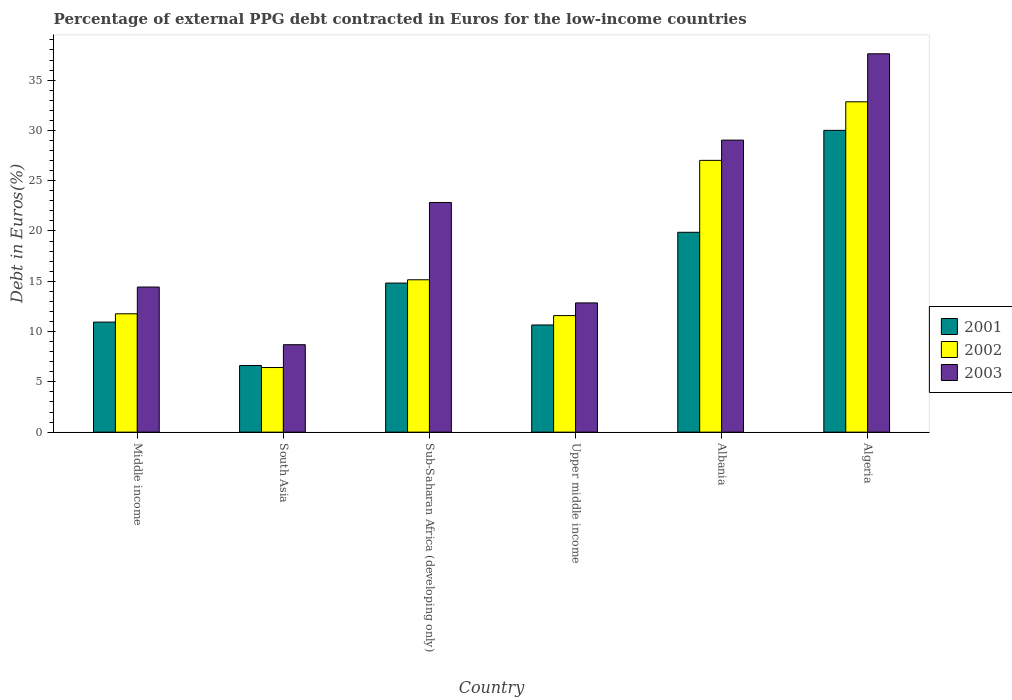How many groups of bars are there?
Offer a terse response. 6. How many bars are there on the 2nd tick from the left?
Offer a very short reply. 3. What is the label of the 6th group of bars from the left?
Your response must be concise. Algeria. In how many cases, is the number of bars for a given country not equal to the number of legend labels?
Keep it short and to the point. 0. What is the percentage of external PPG debt contracted in Euros in 2003 in Albania?
Make the answer very short. 29.04. Across all countries, what is the maximum percentage of external PPG debt contracted in Euros in 2003?
Provide a short and direct response. 37.62. Across all countries, what is the minimum percentage of external PPG debt contracted in Euros in 2001?
Provide a short and direct response. 6.62. In which country was the percentage of external PPG debt contracted in Euros in 2003 maximum?
Provide a succinct answer. Algeria. In which country was the percentage of external PPG debt contracted in Euros in 2001 minimum?
Ensure brevity in your answer.  South Asia. What is the total percentage of external PPG debt contracted in Euros in 2001 in the graph?
Your answer should be compact. 92.92. What is the difference between the percentage of external PPG debt contracted in Euros in 2002 in Algeria and that in Sub-Saharan Africa (developing only)?
Give a very brief answer. 17.7. What is the difference between the percentage of external PPG debt contracted in Euros in 2003 in Middle income and the percentage of external PPG debt contracted in Euros in 2001 in South Asia?
Your answer should be compact. 7.8. What is the average percentage of external PPG debt contracted in Euros in 2002 per country?
Your response must be concise. 17.47. What is the difference between the percentage of external PPG debt contracted in Euros of/in 2001 and percentage of external PPG debt contracted in Euros of/in 2003 in Sub-Saharan Africa (developing only)?
Provide a short and direct response. -8.01. In how many countries, is the percentage of external PPG debt contracted in Euros in 2002 greater than 16 %?
Provide a succinct answer. 2. What is the ratio of the percentage of external PPG debt contracted in Euros in 2002 in Albania to that in Middle income?
Your answer should be very brief. 2.3. Is the percentage of external PPG debt contracted in Euros in 2003 in Algeria less than that in Sub-Saharan Africa (developing only)?
Your answer should be compact. No. What is the difference between the highest and the second highest percentage of external PPG debt contracted in Euros in 2001?
Provide a succinct answer. -10.14. What is the difference between the highest and the lowest percentage of external PPG debt contracted in Euros in 2003?
Your response must be concise. 28.93. Are all the bars in the graph horizontal?
Provide a short and direct response. No. Does the graph contain grids?
Your answer should be very brief. No. Where does the legend appear in the graph?
Ensure brevity in your answer.  Center right. What is the title of the graph?
Your response must be concise. Percentage of external PPG debt contracted in Euros for the low-income countries. Does "1980" appear as one of the legend labels in the graph?
Keep it short and to the point. No. What is the label or title of the Y-axis?
Your response must be concise. Debt in Euros(%). What is the Debt in Euros(%) in 2001 in Middle income?
Give a very brief answer. 10.94. What is the Debt in Euros(%) of 2002 in Middle income?
Ensure brevity in your answer.  11.77. What is the Debt in Euros(%) in 2003 in Middle income?
Provide a succinct answer. 14.43. What is the Debt in Euros(%) in 2001 in South Asia?
Offer a terse response. 6.62. What is the Debt in Euros(%) in 2002 in South Asia?
Ensure brevity in your answer.  6.43. What is the Debt in Euros(%) of 2003 in South Asia?
Offer a very short reply. 8.69. What is the Debt in Euros(%) of 2001 in Sub-Saharan Africa (developing only)?
Make the answer very short. 14.82. What is the Debt in Euros(%) of 2002 in Sub-Saharan Africa (developing only)?
Offer a very short reply. 15.15. What is the Debt in Euros(%) in 2003 in Sub-Saharan Africa (developing only)?
Your answer should be very brief. 22.84. What is the Debt in Euros(%) in 2001 in Upper middle income?
Offer a very short reply. 10.66. What is the Debt in Euros(%) of 2002 in Upper middle income?
Ensure brevity in your answer.  11.59. What is the Debt in Euros(%) in 2003 in Upper middle income?
Provide a short and direct response. 12.85. What is the Debt in Euros(%) of 2001 in Albania?
Your answer should be very brief. 19.87. What is the Debt in Euros(%) in 2002 in Albania?
Provide a short and direct response. 27.02. What is the Debt in Euros(%) of 2003 in Albania?
Provide a succinct answer. 29.04. What is the Debt in Euros(%) in 2001 in Algeria?
Offer a terse response. 30.01. What is the Debt in Euros(%) in 2002 in Algeria?
Your answer should be compact. 32.85. What is the Debt in Euros(%) in 2003 in Algeria?
Make the answer very short. 37.62. Across all countries, what is the maximum Debt in Euros(%) of 2001?
Your answer should be very brief. 30.01. Across all countries, what is the maximum Debt in Euros(%) in 2002?
Offer a very short reply. 32.85. Across all countries, what is the maximum Debt in Euros(%) of 2003?
Offer a very short reply. 37.62. Across all countries, what is the minimum Debt in Euros(%) of 2001?
Your answer should be very brief. 6.62. Across all countries, what is the minimum Debt in Euros(%) in 2002?
Give a very brief answer. 6.43. Across all countries, what is the minimum Debt in Euros(%) of 2003?
Your response must be concise. 8.69. What is the total Debt in Euros(%) of 2001 in the graph?
Ensure brevity in your answer.  92.92. What is the total Debt in Euros(%) in 2002 in the graph?
Give a very brief answer. 104.8. What is the total Debt in Euros(%) of 2003 in the graph?
Your answer should be very brief. 125.46. What is the difference between the Debt in Euros(%) in 2001 in Middle income and that in South Asia?
Your answer should be very brief. 4.32. What is the difference between the Debt in Euros(%) of 2002 in Middle income and that in South Asia?
Make the answer very short. 5.34. What is the difference between the Debt in Euros(%) of 2003 in Middle income and that in South Asia?
Ensure brevity in your answer.  5.73. What is the difference between the Debt in Euros(%) in 2001 in Middle income and that in Sub-Saharan Africa (developing only)?
Provide a short and direct response. -3.88. What is the difference between the Debt in Euros(%) in 2002 in Middle income and that in Sub-Saharan Africa (developing only)?
Your answer should be compact. -3.38. What is the difference between the Debt in Euros(%) of 2003 in Middle income and that in Sub-Saharan Africa (developing only)?
Your answer should be very brief. -8.41. What is the difference between the Debt in Euros(%) of 2001 in Middle income and that in Upper middle income?
Your answer should be very brief. 0.29. What is the difference between the Debt in Euros(%) in 2002 in Middle income and that in Upper middle income?
Give a very brief answer. 0.18. What is the difference between the Debt in Euros(%) in 2003 in Middle income and that in Upper middle income?
Your answer should be compact. 1.58. What is the difference between the Debt in Euros(%) in 2001 in Middle income and that in Albania?
Your answer should be very brief. -8.93. What is the difference between the Debt in Euros(%) in 2002 in Middle income and that in Albania?
Ensure brevity in your answer.  -15.25. What is the difference between the Debt in Euros(%) of 2003 in Middle income and that in Albania?
Provide a succinct answer. -14.61. What is the difference between the Debt in Euros(%) of 2001 in Middle income and that in Algeria?
Give a very brief answer. -19.06. What is the difference between the Debt in Euros(%) in 2002 in Middle income and that in Algeria?
Provide a short and direct response. -21.08. What is the difference between the Debt in Euros(%) of 2003 in Middle income and that in Algeria?
Give a very brief answer. -23.19. What is the difference between the Debt in Euros(%) in 2001 in South Asia and that in Sub-Saharan Africa (developing only)?
Ensure brevity in your answer.  -8.2. What is the difference between the Debt in Euros(%) in 2002 in South Asia and that in Sub-Saharan Africa (developing only)?
Provide a short and direct response. -8.72. What is the difference between the Debt in Euros(%) in 2003 in South Asia and that in Sub-Saharan Africa (developing only)?
Offer a terse response. -14.14. What is the difference between the Debt in Euros(%) in 2001 in South Asia and that in Upper middle income?
Offer a very short reply. -4.03. What is the difference between the Debt in Euros(%) in 2002 in South Asia and that in Upper middle income?
Your answer should be very brief. -5.16. What is the difference between the Debt in Euros(%) of 2003 in South Asia and that in Upper middle income?
Your answer should be very brief. -4.16. What is the difference between the Debt in Euros(%) in 2001 in South Asia and that in Albania?
Give a very brief answer. -13.25. What is the difference between the Debt in Euros(%) in 2002 in South Asia and that in Albania?
Offer a terse response. -20.6. What is the difference between the Debt in Euros(%) in 2003 in South Asia and that in Albania?
Offer a terse response. -20.34. What is the difference between the Debt in Euros(%) of 2001 in South Asia and that in Algeria?
Provide a short and direct response. -23.38. What is the difference between the Debt in Euros(%) of 2002 in South Asia and that in Algeria?
Make the answer very short. -26.42. What is the difference between the Debt in Euros(%) of 2003 in South Asia and that in Algeria?
Provide a succinct answer. -28.93. What is the difference between the Debt in Euros(%) in 2001 in Sub-Saharan Africa (developing only) and that in Upper middle income?
Offer a very short reply. 4.17. What is the difference between the Debt in Euros(%) of 2002 in Sub-Saharan Africa (developing only) and that in Upper middle income?
Provide a short and direct response. 3.56. What is the difference between the Debt in Euros(%) in 2003 in Sub-Saharan Africa (developing only) and that in Upper middle income?
Your response must be concise. 9.99. What is the difference between the Debt in Euros(%) in 2001 in Sub-Saharan Africa (developing only) and that in Albania?
Your answer should be very brief. -5.05. What is the difference between the Debt in Euros(%) in 2002 in Sub-Saharan Africa (developing only) and that in Albania?
Your response must be concise. -11.87. What is the difference between the Debt in Euros(%) in 2003 in Sub-Saharan Africa (developing only) and that in Albania?
Your response must be concise. -6.2. What is the difference between the Debt in Euros(%) of 2001 in Sub-Saharan Africa (developing only) and that in Algeria?
Offer a very short reply. -15.18. What is the difference between the Debt in Euros(%) of 2002 in Sub-Saharan Africa (developing only) and that in Algeria?
Your answer should be compact. -17.7. What is the difference between the Debt in Euros(%) of 2003 in Sub-Saharan Africa (developing only) and that in Algeria?
Offer a very short reply. -14.78. What is the difference between the Debt in Euros(%) in 2001 in Upper middle income and that in Albania?
Give a very brief answer. -9.22. What is the difference between the Debt in Euros(%) of 2002 in Upper middle income and that in Albania?
Your answer should be very brief. -15.43. What is the difference between the Debt in Euros(%) in 2003 in Upper middle income and that in Albania?
Make the answer very short. -16.19. What is the difference between the Debt in Euros(%) in 2001 in Upper middle income and that in Algeria?
Provide a succinct answer. -19.35. What is the difference between the Debt in Euros(%) in 2002 in Upper middle income and that in Algeria?
Your answer should be very brief. -21.26. What is the difference between the Debt in Euros(%) of 2003 in Upper middle income and that in Algeria?
Your response must be concise. -24.77. What is the difference between the Debt in Euros(%) of 2001 in Albania and that in Algeria?
Your response must be concise. -10.14. What is the difference between the Debt in Euros(%) of 2002 in Albania and that in Algeria?
Ensure brevity in your answer.  -5.82. What is the difference between the Debt in Euros(%) in 2003 in Albania and that in Algeria?
Your response must be concise. -8.58. What is the difference between the Debt in Euros(%) in 2001 in Middle income and the Debt in Euros(%) in 2002 in South Asia?
Offer a terse response. 4.52. What is the difference between the Debt in Euros(%) of 2001 in Middle income and the Debt in Euros(%) of 2003 in South Asia?
Provide a succinct answer. 2.25. What is the difference between the Debt in Euros(%) in 2002 in Middle income and the Debt in Euros(%) in 2003 in South Asia?
Your answer should be compact. 3.07. What is the difference between the Debt in Euros(%) of 2001 in Middle income and the Debt in Euros(%) of 2002 in Sub-Saharan Africa (developing only)?
Provide a short and direct response. -4.21. What is the difference between the Debt in Euros(%) of 2001 in Middle income and the Debt in Euros(%) of 2003 in Sub-Saharan Africa (developing only)?
Your answer should be compact. -11.89. What is the difference between the Debt in Euros(%) of 2002 in Middle income and the Debt in Euros(%) of 2003 in Sub-Saharan Africa (developing only)?
Provide a short and direct response. -11.07. What is the difference between the Debt in Euros(%) in 2001 in Middle income and the Debt in Euros(%) in 2002 in Upper middle income?
Your answer should be very brief. -0.64. What is the difference between the Debt in Euros(%) in 2001 in Middle income and the Debt in Euros(%) in 2003 in Upper middle income?
Keep it short and to the point. -1.91. What is the difference between the Debt in Euros(%) of 2002 in Middle income and the Debt in Euros(%) of 2003 in Upper middle income?
Your response must be concise. -1.08. What is the difference between the Debt in Euros(%) of 2001 in Middle income and the Debt in Euros(%) of 2002 in Albania?
Offer a very short reply. -16.08. What is the difference between the Debt in Euros(%) in 2001 in Middle income and the Debt in Euros(%) in 2003 in Albania?
Provide a short and direct response. -18.09. What is the difference between the Debt in Euros(%) in 2002 in Middle income and the Debt in Euros(%) in 2003 in Albania?
Provide a succinct answer. -17.27. What is the difference between the Debt in Euros(%) in 2001 in Middle income and the Debt in Euros(%) in 2002 in Algeria?
Offer a terse response. -21.9. What is the difference between the Debt in Euros(%) of 2001 in Middle income and the Debt in Euros(%) of 2003 in Algeria?
Offer a very short reply. -26.68. What is the difference between the Debt in Euros(%) in 2002 in Middle income and the Debt in Euros(%) in 2003 in Algeria?
Your response must be concise. -25.85. What is the difference between the Debt in Euros(%) in 2001 in South Asia and the Debt in Euros(%) in 2002 in Sub-Saharan Africa (developing only)?
Provide a succinct answer. -8.53. What is the difference between the Debt in Euros(%) in 2001 in South Asia and the Debt in Euros(%) in 2003 in Sub-Saharan Africa (developing only)?
Offer a terse response. -16.21. What is the difference between the Debt in Euros(%) in 2002 in South Asia and the Debt in Euros(%) in 2003 in Sub-Saharan Africa (developing only)?
Offer a terse response. -16.41. What is the difference between the Debt in Euros(%) in 2001 in South Asia and the Debt in Euros(%) in 2002 in Upper middle income?
Your answer should be compact. -4.96. What is the difference between the Debt in Euros(%) of 2001 in South Asia and the Debt in Euros(%) of 2003 in Upper middle income?
Provide a succinct answer. -6.23. What is the difference between the Debt in Euros(%) of 2002 in South Asia and the Debt in Euros(%) of 2003 in Upper middle income?
Offer a very short reply. -6.42. What is the difference between the Debt in Euros(%) in 2001 in South Asia and the Debt in Euros(%) in 2002 in Albania?
Keep it short and to the point. -20.4. What is the difference between the Debt in Euros(%) in 2001 in South Asia and the Debt in Euros(%) in 2003 in Albania?
Ensure brevity in your answer.  -22.41. What is the difference between the Debt in Euros(%) of 2002 in South Asia and the Debt in Euros(%) of 2003 in Albania?
Offer a very short reply. -22.61. What is the difference between the Debt in Euros(%) in 2001 in South Asia and the Debt in Euros(%) in 2002 in Algeria?
Ensure brevity in your answer.  -26.22. What is the difference between the Debt in Euros(%) in 2001 in South Asia and the Debt in Euros(%) in 2003 in Algeria?
Offer a terse response. -31. What is the difference between the Debt in Euros(%) of 2002 in South Asia and the Debt in Euros(%) of 2003 in Algeria?
Ensure brevity in your answer.  -31.19. What is the difference between the Debt in Euros(%) of 2001 in Sub-Saharan Africa (developing only) and the Debt in Euros(%) of 2002 in Upper middle income?
Your answer should be compact. 3.23. What is the difference between the Debt in Euros(%) in 2001 in Sub-Saharan Africa (developing only) and the Debt in Euros(%) in 2003 in Upper middle income?
Offer a terse response. 1.97. What is the difference between the Debt in Euros(%) in 2002 in Sub-Saharan Africa (developing only) and the Debt in Euros(%) in 2003 in Upper middle income?
Make the answer very short. 2.3. What is the difference between the Debt in Euros(%) in 2001 in Sub-Saharan Africa (developing only) and the Debt in Euros(%) in 2002 in Albania?
Provide a succinct answer. -12.2. What is the difference between the Debt in Euros(%) of 2001 in Sub-Saharan Africa (developing only) and the Debt in Euros(%) of 2003 in Albania?
Keep it short and to the point. -14.21. What is the difference between the Debt in Euros(%) in 2002 in Sub-Saharan Africa (developing only) and the Debt in Euros(%) in 2003 in Albania?
Provide a short and direct response. -13.89. What is the difference between the Debt in Euros(%) of 2001 in Sub-Saharan Africa (developing only) and the Debt in Euros(%) of 2002 in Algeria?
Provide a short and direct response. -18.02. What is the difference between the Debt in Euros(%) of 2001 in Sub-Saharan Africa (developing only) and the Debt in Euros(%) of 2003 in Algeria?
Keep it short and to the point. -22.8. What is the difference between the Debt in Euros(%) of 2002 in Sub-Saharan Africa (developing only) and the Debt in Euros(%) of 2003 in Algeria?
Provide a succinct answer. -22.47. What is the difference between the Debt in Euros(%) of 2001 in Upper middle income and the Debt in Euros(%) of 2002 in Albania?
Ensure brevity in your answer.  -16.37. What is the difference between the Debt in Euros(%) in 2001 in Upper middle income and the Debt in Euros(%) in 2003 in Albania?
Provide a succinct answer. -18.38. What is the difference between the Debt in Euros(%) of 2002 in Upper middle income and the Debt in Euros(%) of 2003 in Albania?
Provide a succinct answer. -17.45. What is the difference between the Debt in Euros(%) of 2001 in Upper middle income and the Debt in Euros(%) of 2002 in Algeria?
Your answer should be compact. -22.19. What is the difference between the Debt in Euros(%) in 2001 in Upper middle income and the Debt in Euros(%) in 2003 in Algeria?
Provide a short and direct response. -26.96. What is the difference between the Debt in Euros(%) in 2002 in Upper middle income and the Debt in Euros(%) in 2003 in Algeria?
Your answer should be very brief. -26.03. What is the difference between the Debt in Euros(%) of 2001 in Albania and the Debt in Euros(%) of 2002 in Algeria?
Your response must be concise. -12.97. What is the difference between the Debt in Euros(%) of 2001 in Albania and the Debt in Euros(%) of 2003 in Algeria?
Offer a terse response. -17.75. What is the difference between the Debt in Euros(%) in 2002 in Albania and the Debt in Euros(%) in 2003 in Algeria?
Give a very brief answer. -10.6. What is the average Debt in Euros(%) in 2001 per country?
Offer a very short reply. 15.49. What is the average Debt in Euros(%) in 2002 per country?
Your answer should be compact. 17.47. What is the average Debt in Euros(%) of 2003 per country?
Give a very brief answer. 20.91. What is the difference between the Debt in Euros(%) of 2001 and Debt in Euros(%) of 2002 in Middle income?
Ensure brevity in your answer.  -0.82. What is the difference between the Debt in Euros(%) of 2001 and Debt in Euros(%) of 2003 in Middle income?
Provide a short and direct response. -3.48. What is the difference between the Debt in Euros(%) in 2002 and Debt in Euros(%) in 2003 in Middle income?
Provide a succinct answer. -2.66. What is the difference between the Debt in Euros(%) in 2001 and Debt in Euros(%) in 2002 in South Asia?
Offer a terse response. 0.2. What is the difference between the Debt in Euros(%) of 2001 and Debt in Euros(%) of 2003 in South Asia?
Make the answer very short. -2.07. What is the difference between the Debt in Euros(%) in 2002 and Debt in Euros(%) in 2003 in South Asia?
Provide a short and direct response. -2.27. What is the difference between the Debt in Euros(%) in 2001 and Debt in Euros(%) in 2002 in Sub-Saharan Africa (developing only)?
Provide a short and direct response. -0.33. What is the difference between the Debt in Euros(%) of 2001 and Debt in Euros(%) of 2003 in Sub-Saharan Africa (developing only)?
Offer a very short reply. -8.01. What is the difference between the Debt in Euros(%) of 2002 and Debt in Euros(%) of 2003 in Sub-Saharan Africa (developing only)?
Ensure brevity in your answer.  -7.69. What is the difference between the Debt in Euros(%) in 2001 and Debt in Euros(%) in 2002 in Upper middle income?
Provide a short and direct response. -0.93. What is the difference between the Debt in Euros(%) in 2001 and Debt in Euros(%) in 2003 in Upper middle income?
Keep it short and to the point. -2.19. What is the difference between the Debt in Euros(%) in 2002 and Debt in Euros(%) in 2003 in Upper middle income?
Your response must be concise. -1.26. What is the difference between the Debt in Euros(%) in 2001 and Debt in Euros(%) in 2002 in Albania?
Offer a very short reply. -7.15. What is the difference between the Debt in Euros(%) in 2001 and Debt in Euros(%) in 2003 in Albania?
Offer a very short reply. -9.16. What is the difference between the Debt in Euros(%) of 2002 and Debt in Euros(%) of 2003 in Albania?
Keep it short and to the point. -2.01. What is the difference between the Debt in Euros(%) in 2001 and Debt in Euros(%) in 2002 in Algeria?
Ensure brevity in your answer.  -2.84. What is the difference between the Debt in Euros(%) of 2001 and Debt in Euros(%) of 2003 in Algeria?
Offer a very short reply. -7.61. What is the difference between the Debt in Euros(%) of 2002 and Debt in Euros(%) of 2003 in Algeria?
Make the answer very short. -4.77. What is the ratio of the Debt in Euros(%) of 2001 in Middle income to that in South Asia?
Provide a succinct answer. 1.65. What is the ratio of the Debt in Euros(%) in 2002 in Middle income to that in South Asia?
Your answer should be compact. 1.83. What is the ratio of the Debt in Euros(%) in 2003 in Middle income to that in South Asia?
Offer a terse response. 1.66. What is the ratio of the Debt in Euros(%) of 2001 in Middle income to that in Sub-Saharan Africa (developing only)?
Give a very brief answer. 0.74. What is the ratio of the Debt in Euros(%) of 2002 in Middle income to that in Sub-Saharan Africa (developing only)?
Your response must be concise. 0.78. What is the ratio of the Debt in Euros(%) of 2003 in Middle income to that in Sub-Saharan Africa (developing only)?
Provide a succinct answer. 0.63. What is the ratio of the Debt in Euros(%) in 2001 in Middle income to that in Upper middle income?
Your response must be concise. 1.03. What is the ratio of the Debt in Euros(%) of 2002 in Middle income to that in Upper middle income?
Your answer should be compact. 1.02. What is the ratio of the Debt in Euros(%) in 2003 in Middle income to that in Upper middle income?
Offer a very short reply. 1.12. What is the ratio of the Debt in Euros(%) in 2001 in Middle income to that in Albania?
Your answer should be compact. 0.55. What is the ratio of the Debt in Euros(%) of 2002 in Middle income to that in Albania?
Offer a very short reply. 0.44. What is the ratio of the Debt in Euros(%) of 2003 in Middle income to that in Albania?
Provide a succinct answer. 0.5. What is the ratio of the Debt in Euros(%) of 2001 in Middle income to that in Algeria?
Offer a very short reply. 0.36. What is the ratio of the Debt in Euros(%) in 2002 in Middle income to that in Algeria?
Your answer should be compact. 0.36. What is the ratio of the Debt in Euros(%) of 2003 in Middle income to that in Algeria?
Keep it short and to the point. 0.38. What is the ratio of the Debt in Euros(%) in 2001 in South Asia to that in Sub-Saharan Africa (developing only)?
Your answer should be compact. 0.45. What is the ratio of the Debt in Euros(%) of 2002 in South Asia to that in Sub-Saharan Africa (developing only)?
Ensure brevity in your answer.  0.42. What is the ratio of the Debt in Euros(%) of 2003 in South Asia to that in Sub-Saharan Africa (developing only)?
Provide a short and direct response. 0.38. What is the ratio of the Debt in Euros(%) in 2001 in South Asia to that in Upper middle income?
Keep it short and to the point. 0.62. What is the ratio of the Debt in Euros(%) of 2002 in South Asia to that in Upper middle income?
Your response must be concise. 0.55. What is the ratio of the Debt in Euros(%) in 2003 in South Asia to that in Upper middle income?
Keep it short and to the point. 0.68. What is the ratio of the Debt in Euros(%) in 2002 in South Asia to that in Albania?
Your response must be concise. 0.24. What is the ratio of the Debt in Euros(%) of 2003 in South Asia to that in Albania?
Give a very brief answer. 0.3. What is the ratio of the Debt in Euros(%) in 2001 in South Asia to that in Algeria?
Ensure brevity in your answer.  0.22. What is the ratio of the Debt in Euros(%) of 2002 in South Asia to that in Algeria?
Make the answer very short. 0.2. What is the ratio of the Debt in Euros(%) in 2003 in South Asia to that in Algeria?
Keep it short and to the point. 0.23. What is the ratio of the Debt in Euros(%) of 2001 in Sub-Saharan Africa (developing only) to that in Upper middle income?
Offer a very short reply. 1.39. What is the ratio of the Debt in Euros(%) of 2002 in Sub-Saharan Africa (developing only) to that in Upper middle income?
Give a very brief answer. 1.31. What is the ratio of the Debt in Euros(%) in 2003 in Sub-Saharan Africa (developing only) to that in Upper middle income?
Your answer should be very brief. 1.78. What is the ratio of the Debt in Euros(%) of 2001 in Sub-Saharan Africa (developing only) to that in Albania?
Ensure brevity in your answer.  0.75. What is the ratio of the Debt in Euros(%) in 2002 in Sub-Saharan Africa (developing only) to that in Albania?
Your answer should be very brief. 0.56. What is the ratio of the Debt in Euros(%) in 2003 in Sub-Saharan Africa (developing only) to that in Albania?
Ensure brevity in your answer.  0.79. What is the ratio of the Debt in Euros(%) of 2001 in Sub-Saharan Africa (developing only) to that in Algeria?
Provide a succinct answer. 0.49. What is the ratio of the Debt in Euros(%) of 2002 in Sub-Saharan Africa (developing only) to that in Algeria?
Offer a very short reply. 0.46. What is the ratio of the Debt in Euros(%) in 2003 in Sub-Saharan Africa (developing only) to that in Algeria?
Offer a very short reply. 0.61. What is the ratio of the Debt in Euros(%) in 2001 in Upper middle income to that in Albania?
Provide a succinct answer. 0.54. What is the ratio of the Debt in Euros(%) in 2002 in Upper middle income to that in Albania?
Your response must be concise. 0.43. What is the ratio of the Debt in Euros(%) in 2003 in Upper middle income to that in Albania?
Provide a short and direct response. 0.44. What is the ratio of the Debt in Euros(%) in 2001 in Upper middle income to that in Algeria?
Your answer should be very brief. 0.36. What is the ratio of the Debt in Euros(%) in 2002 in Upper middle income to that in Algeria?
Your answer should be very brief. 0.35. What is the ratio of the Debt in Euros(%) of 2003 in Upper middle income to that in Algeria?
Your answer should be compact. 0.34. What is the ratio of the Debt in Euros(%) of 2001 in Albania to that in Algeria?
Your response must be concise. 0.66. What is the ratio of the Debt in Euros(%) in 2002 in Albania to that in Algeria?
Offer a very short reply. 0.82. What is the ratio of the Debt in Euros(%) of 2003 in Albania to that in Algeria?
Ensure brevity in your answer.  0.77. What is the difference between the highest and the second highest Debt in Euros(%) of 2001?
Provide a succinct answer. 10.14. What is the difference between the highest and the second highest Debt in Euros(%) in 2002?
Your answer should be very brief. 5.82. What is the difference between the highest and the second highest Debt in Euros(%) in 2003?
Ensure brevity in your answer.  8.58. What is the difference between the highest and the lowest Debt in Euros(%) in 2001?
Provide a short and direct response. 23.38. What is the difference between the highest and the lowest Debt in Euros(%) in 2002?
Your answer should be very brief. 26.42. What is the difference between the highest and the lowest Debt in Euros(%) of 2003?
Ensure brevity in your answer.  28.93. 